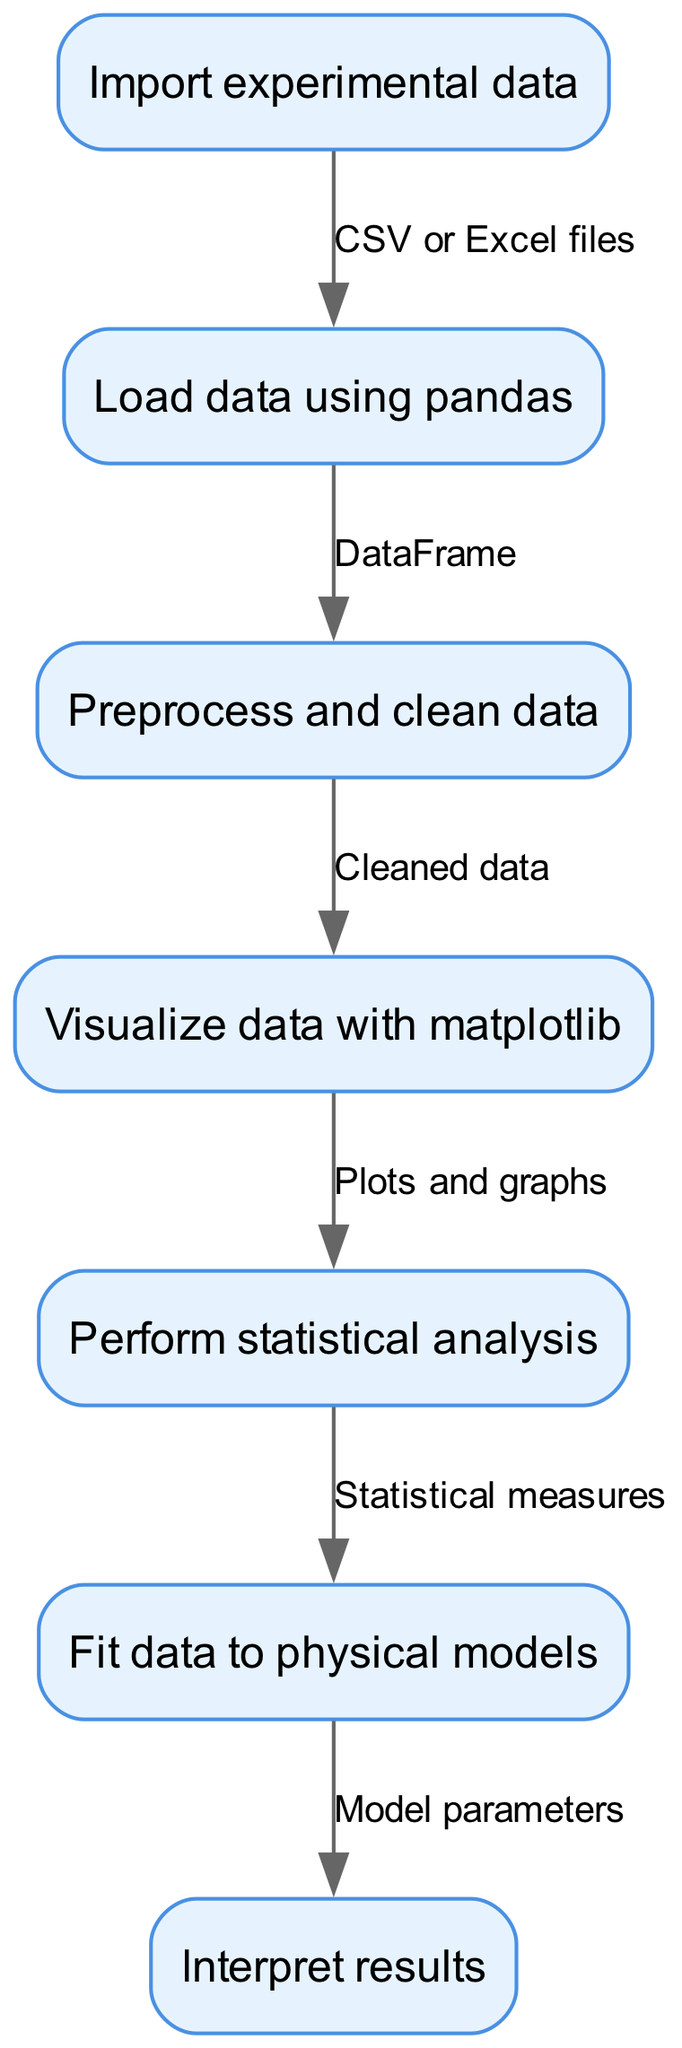What is the first step in the workflow? The diagram indicates that the first step, represented by the first node, is "Import experimental data."
Answer: Import experimental data How many nodes are in the diagram? By counting each distinct step, we find that there are 7 nodes present in the diagram detailing different parts of the workflow.
Answer: 7 What type of files does the workflow suggest for importing data? The edge from the first node to the second node specifies "CSV or Excel files" as the types of files used for data import.
Answer: CSV or Excel files Which node comes after preprocessing the data? The sequence in the diagram shows that after the "Preprocess and clean data" step, the next node is "Visualize data with matplotlib."
Answer: Visualize data with matplotlib What statistical outcome follows after performing statistical analysis? The flow indicates that after completing statistical analysis, the process leads to the node "Fit data to physical models."
Answer: Fit data to physical models What connects data loading to data preprocessing? The edge connecting node 2 ("Load data using pandas") to node 3 ("Preprocess and clean data") implies the relationship is that the output is a "DataFrame."
Answer: DataFrame What is the final step in the workflow? The last node in the sequence is "Interpret results," indicating that interpretation of results is the concluding activity of the workflow.
Answer: Interpret results How many edges are there connecting the nodes? By examining the connections (edges) between the nodes, we see there are 6 edges that link different steps in the workflow together.
Answer: 6 